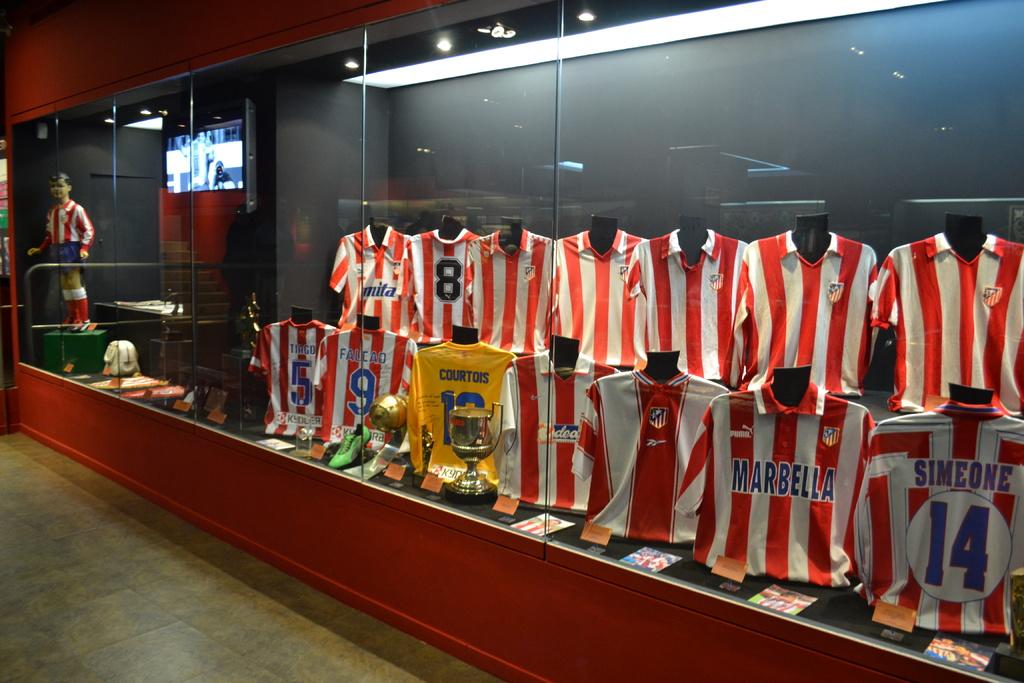What number is the jersey with the name simeone on it?
Your answer should be compact. 14. 